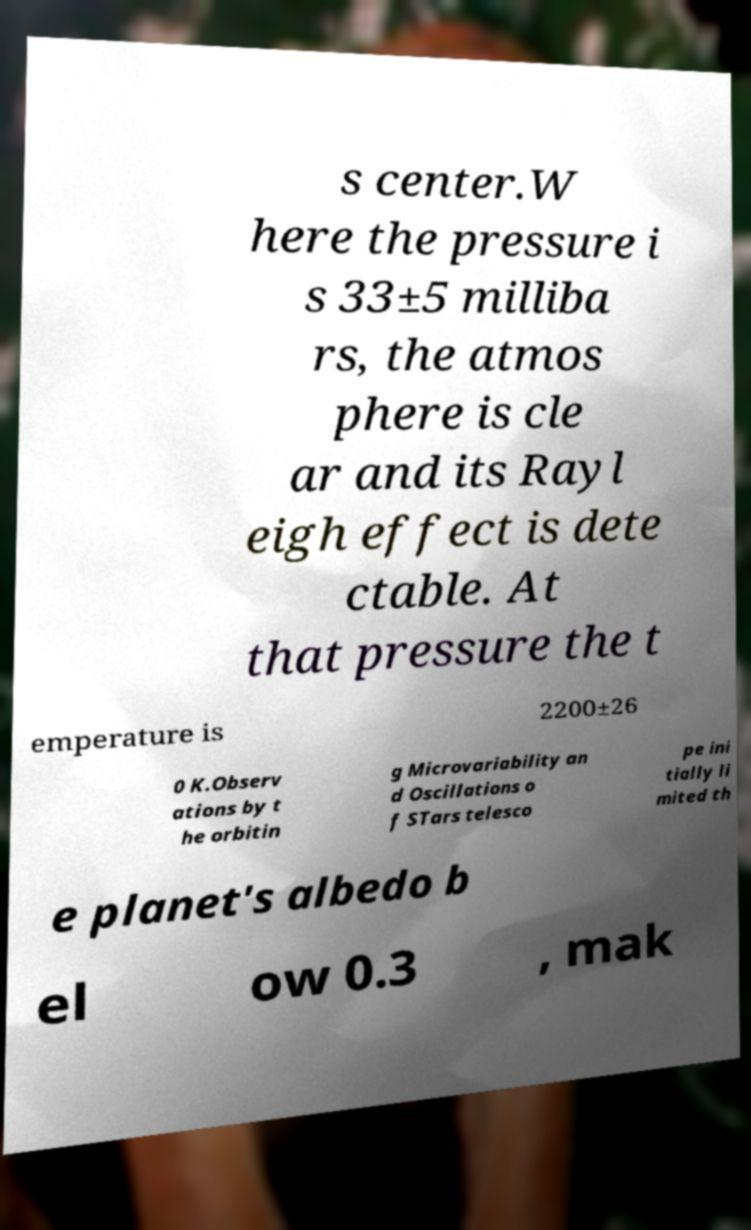Can you accurately transcribe the text from the provided image for me? s center.W here the pressure i s 33±5 milliba rs, the atmos phere is cle ar and its Rayl eigh effect is dete ctable. At that pressure the t emperature is 2200±26 0 K.Observ ations by t he orbitin g Microvariability an d Oscillations o f STars telesco pe ini tially li mited th e planet's albedo b el ow 0.3 , mak 